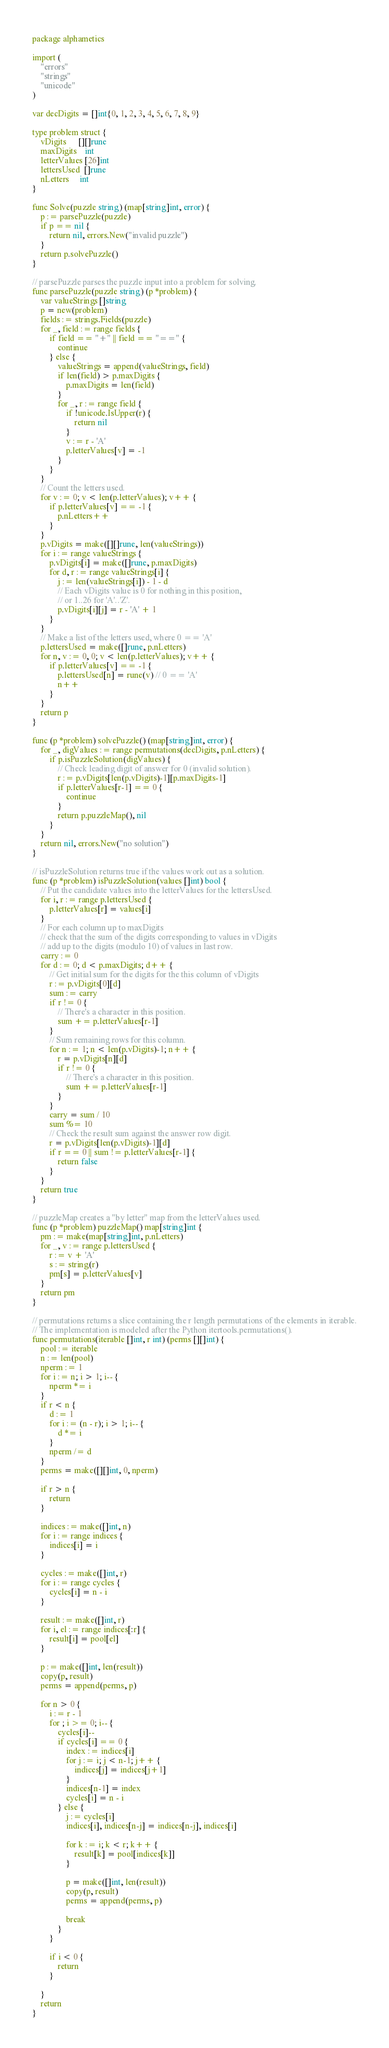Convert code to text. <code><loc_0><loc_0><loc_500><loc_500><_Go_>package alphametics

import (
	"errors"
	"strings"
	"unicode"
)

var decDigits = []int{0, 1, 2, 3, 4, 5, 6, 7, 8, 9}

type problem struct {
	vDigits      [][]rune
	maxDigits    int
	letterValues [26]int
	lettersUsed  []rune
	nLetters     int
}

func Solve(puzzle string) (map[string]int, error) {
	p := parsePuzzle(puzzle)
	if p == nil {
		return nil, errors.New("invalid puzzle")
	}
	return p.solvePuzzle()
}

// parsePuzzle parses the puzzle input into a problem for solving.
func parsePuzzle(puzzle string) (p *problem) {
	var valueStrings []string
	p = new(problem)
	fields := strings.Fields(puzzle)
	for _, field := range fields {
		if field == "+" || field == "==" {
			continue
		} else {
			valueStrings = append(valueStrings, field)
			if len(field) > p.maxDigits {
				p.maxDigits = len(field)
			}
			for _, r := range field {
				if !unicode.IsUpper(r) {
					return nil
				}
				v := r - 'A'
				p.letterValues[v] = -1
			}
		}
	}
	// Count the letters used.
	for v := 0; v < len(p.letterValues); v++ {
		if p.letterValues[v] == -1 {
			p.nLetters++
		}
	}
	p.vDigits = make([][]rune, len(valueStrings))
	for i := range valueStrings {
		p.vDigits[i] = make([]rune, p.maxDigits)
		for d, r := range valueStrings[i] {
			j := len(valueStrings[i]) - 1 - d
			// Each vDigits value is 0 for nothing in this position,
			// or 1..26 for 'A'..'Z'.
			p.vDigits[i][j] = r - 'A' + 1
		}
	}
	// Make a list of the letters used, where 0 == 'A'
	p.lettersUsed = make([]rune, p.nLetters)
	for n, v := 0, 0; v < len(p.letterValues); v++ {
		if p.letterValues[v] == -1 {
			p.lettersUsed[n] = rune(v) // 0 == 'A'
			n++
		}
	}
	return p
}

func (p *problem) solvePuzzle() (map[string]int, error) {
	for _, digValues := range permutations(decDigits, p.nLetters) {
		if p.isPuzzleSolution(digValues) {
			// Check leading digit of answer for 0 (invalid solution).
			r := p.vDigits[len(p.vDigits)-1][p.maxDigits-1]
			if p.letterValues[r-1] == 0 {
				continue
			}
			return p.puzzleMap(), nil
		}
	}
	return nil, errors.New("no solution")
}

// isPuzzleSolution returns true if the values work out as a solution.
func (p *problem) isPuzzleSolution(values []int) bool {
	// Put the candidate values into the letterValues for the lettersUsed.
	for i, r := range p.lettersUsed {
		p.letterValues[r] = values[i]
	}
	// For each column up to maxDigits
	// check that the sum of the digits corresponding to values in vDigits
	// add up to the digits (modulo 10) of values in last row.
	carry := 0
	for d := 0; d < p.maxDigits; d++ {
		// Get initial sum for the digits for the this column of vDigits
		r := p.vDigits[0][d]
		sum := carry
		if r != 0 {
			// There's a character in this position.
			sum += p.letterValues[r-1]
		}
		// Sum remaining rows for this column.
		for n := 1; n < len(p.vDigits)-1; n++ {
			r = p.vDigits[n][d]
			if r != 0 {
				// There's a character in this position.
				sum += p.letterValues[r-1]
			}
		}
		carry = sum / 10
		sum %= 10
		// Check the result sum against the answer row digit.
		r = p.vDigits[len(p.vDigits)-1][d]
		if r == 0 || sum != p.letterValues[r-1] {
			return false
		}
	}
	return true
}

// puzzleMap creates a "by letter" map from the letterValues used.
func (p *problem) puzzleMap() map[string]int {
	pm := make(map[string]int, p.nLetters)
	for _, v := range p.lettersUsed {
		r := v + 'A'
		s := string(r)
		pm[s] = p.letterValues[v]
	}
	return pm
}

// permutations returns a slice containing the r length permutations of the elements in iterable.
// The implementation is modeled after the Python itertools.permutations().
func permutations(iterable []int, r int) (perms [][]int) {
	pool := iterable
	n := len(pool)
	nperm := 1
	for i := n; i > 1; i-- {
		nperm *= i
	}
	if r < n {
		d := 1
		for i := (n - r); i > 1; i-- {
			d *= i
		}
		nperm /= d
	}
	perms = make([][]int, 0, nperm)

	if r > n {
		return
	}

	indices := make([]int, n)
	for i := range indices {
		indices[i] = i
	}

	cycles := make([]int, r)
	for i := range cycles {
		cycles[i] = n - i
	}

	result := make([]int, r)
	for i, el := range indices[:r] {
		result[i] = pool[el]
	}

	p := make([]int, len(result))
	copy(p, result)
	perms = append(perms, p)

	for n > 0 {
		i := r - 1
		for ; i >= 0; i-- {
			cycles[i]--
			if cycles[i] == 0 {
				index := indices[i]
				for j := i; j < n-1; j++ {
					indices[j] = indices[j+1]
				}
				indices[n-1] = index
				cycles[i] = n - i
			} else {
				j := cycles[i]
				indices[i], indices[n-j] = indices[n-j], indices[i]

				for k := i; k < r; k++ {
					result[k] = pool[indices[k]]
				}

				p = make([]int, len(result))
				copy(p, result)
				perms = append(perms, p)

				break
			}
		}

		if i < 0 {
			return
		}

	}
	return
}
</code> 